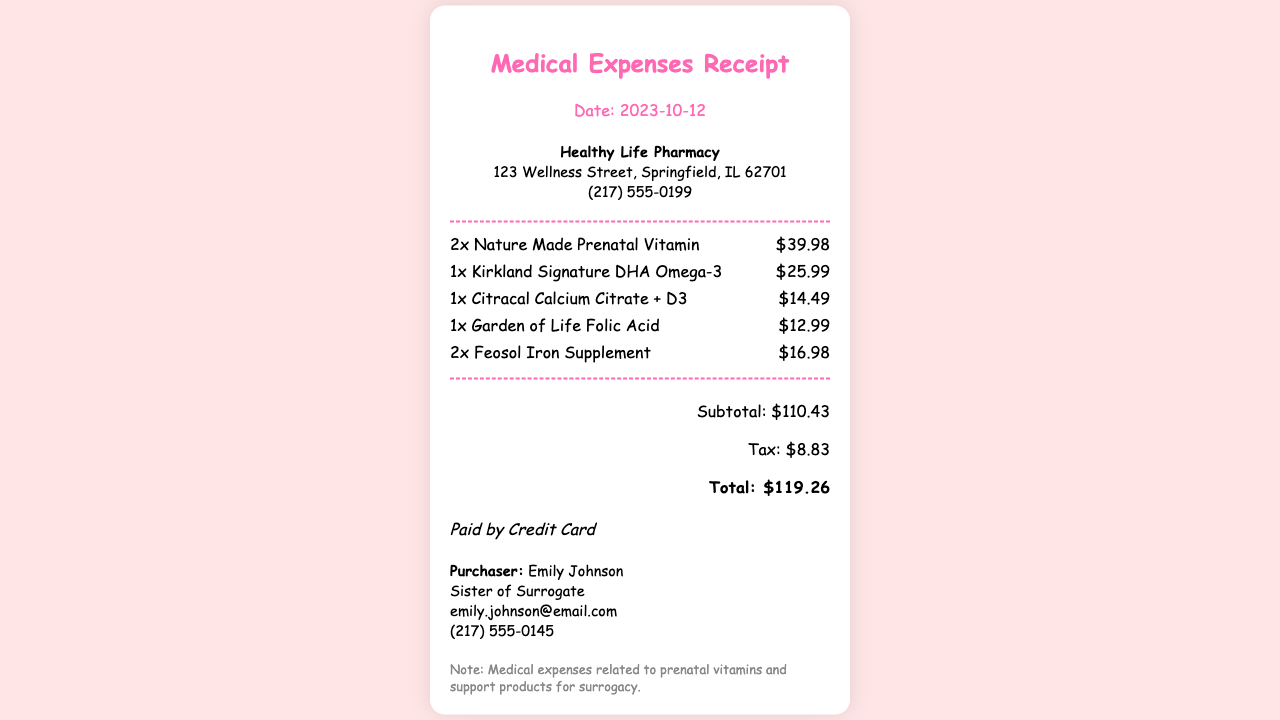What is the date of the receipt? The receipt indicates it was issued on October 12, 2023.
Answer: October 12, 2023 Who is the purchaser? The document states the purchaser's name is Emily Johnson.
Answer: Emily Johnson What is the total amount charged on the receipt? The total amount is specified at the bottom of the receipt as $119.26.
Answer: $119.26 How many Nature Made Prenatal Vitamins were purchased? The receipt lists 2 units of Nature Made Prenatal Vitamins.
Answer: 2 What is the subtotal before tax? The subtotal is provided as $110.43 in the totals section.
Answer: $110.43 What type of card was used for payment? The payment was made by Credit Card, as stated in the document.
Answer: Credit Card What is the address of the pharmacy? The pharmacy's address is detailed as 123 Wellness Street, Springfield, IL 62701.
Answer: 123 Wellness Street, Springfield, IL 62701 What product was purchased in the highest quantity? Nature Made Prenatal Vitamins were purchased in the highest quantity (2x).
Answer: Nature Made Prenatal Vitamin What note is mentioned regarding the expenses? The note indicates that the expenses are related to prenatal vitamins and support products for surrogacy.
Answer: Medical expenses related to prenatal vitamins and support products for surrogacy 